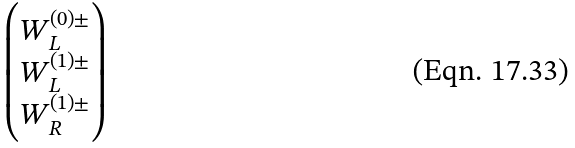Convert formula to latex. <formula><loc_0><loc_0><loc_500><loc_500>\begin{pmatrix} W _ { L } ^ { ( 0 ) \pm } \\ W _ { L } ^ { ( 1 ) \pm } \\ W _ { R } ^ { ( 1 ) \pm } \end{pmatrix}</formula> 